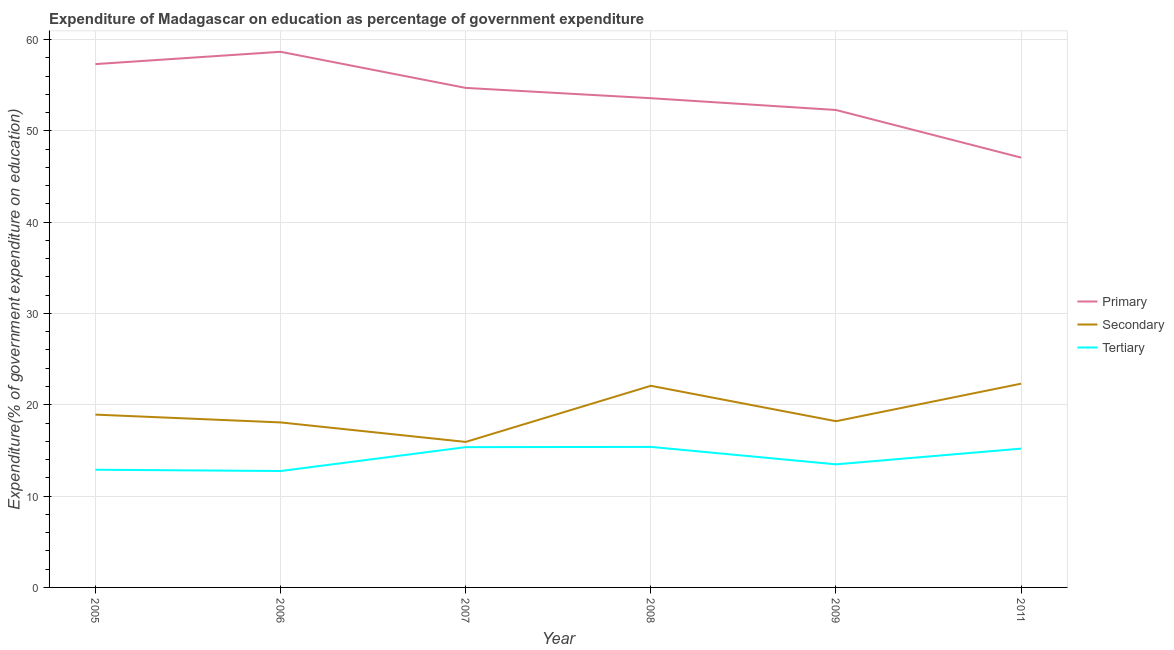Does the line corresponding to expenditure on secondary education intersect with the line corresponding to expenditure on primary education?
Provide a short and direct response. No. What is the expenditure on tertiary education in 2007?
Offer a very short reply. 15.36. Across all years, what is the maximum expenditure on primary education?
Offer a terse response. 58.65. Across all years, what is the minimum expenditure on primary education?
Ensure brevity in your answer.  47.07. In which year was the expenditure on tertiary education maximum?
Offer a terse response. 2008. What is the total expenditure on secondary education in the graph?
Provide a short and direct response. 115.52. What is the difference between the expenditure on primary education in 2005 and that in 2009?
Offer a very short reply. 5.02. What is the difference between the expenditure on primary education in 2006 and the expenditure on tertiary education in 2011?
Provide a succinct answer. 43.45. What is the average expenditure on primary education per year?
Your answer should be very brief. 53.93. In the year 2008, what is the difference between the expenditure on secondary education and expenditure on primary education?
Your answer should be very brief. -31.49. What is the ratio of the expenditure on secondary education in 2005 to that in 2007?
Offer a terse response. 1.19. Is the difference between the expenditure on secondary education in 2005 and 2008 greater than the difference between the expenditure on tertiary education in 2005 and 2008?
Offer a terse response. No. What is the difference between the highest and the second highest expenditure on primary education?
Offer a very short reply. 1.35. What is the difference between the highest and the lowest expenditure on secondary education?
Keep it short and to the point. 6.38. In how many years, is the expenditure on primary education greater than the average expenditure on primary education taken over all years?
Keep it short and to the point. 3. What is the difference between two consecutive major ticks on the Y-axis?
Your answer should be very brief. 10. Are the values on the major ticks of Y-axis written in scientific E-notation?
Provide a succinct answer. No. Does the graph contain any zero values?
Provide a short and direct response. No. Does the graph contain grids?
Provide a succinct answer. Yes. What is the title of the graph?
Make the answer very short. Expenditure of Madagascar on education as percentage of government expenditure. Does "Natural gas sources" appear as one of the legend labels in the graph?
Provide a succinct answer. No. What is the label or title of the Y-axis?
Ensure brevity in your answer.  Expenditure(% of government expenditure on education). What is the Expenditure(% of government expenditure on education) of Primary in 2005?
Provide a short and direct response. 57.31. What is the Expenditure(% of government expenditure on education) of Secondary in 2005?
Give a very brief answer. 18.92. What is the Expenditure(% of government expenditure on education) of Tertiary in 2005?
Offer a terse response. 12.89. What is the Expenditure(% of government expenditure on education) in Primary in 2006?
Your answer should be compact. 58.65. What is the Expenditure(% of government expenditure on education) of Secondary in 2006?
Make the answer very short. 18.07. What is the Expenditure(% of government expenditure on education) of Tertiary in 2006?
Give a very brief answer. 12.75. What is the Expenditure(% of government expenditure on education) in Primary in 2007?
Offer a very short reply. 54.7. What is the Expenditure(% of government expenditure on education) in Secondary in 2007?
Offer a very short reply. 15.93. What is the Expenditure(% of government expenditure on education) of Tertiary in 2007?
Provide a short and direct response. 15.36. What is the Expenditure(% of government expenditure on education) in Primary in 2008?
Offer a very short reply. 53.57. What is the Expenditure(% of government expenditure on education) in Secondary in 2008?
Make the answer very short. 22.08. What is the Expenditure(% of government expenditure on education) in Tertiary in 2008?
Your response must be concise. 15.39. What is the Expenditure(% of government expenditure on education) of Primary in 2009?
Make the answer very short. 52.28. What is the Expenditure(% of government expenditure on education) of Secondary in 2009?
Your response must be concise. 18.2. What is the Expenditure(% of government expenditure on education) of Tertiary in 2009?
Ensure brevity in your answer.  13.48. What is the Expenditure(% of government expenditure on education) in Primary in 2011?
Your answer should be compact. 47.07. What is the Expenditure(% of government expenditure on education) of Secondary in 2011?
Your answer should be very brief. 22.31. What is the Expenditure(% of government expenditure on education) in Tertiary in 2011?
Keep it short and to the point. 15.2. Across all years, what is the maximum Expenditure(% of government expenditure on education) in Primary?
Make the answer very short. 58.65. Across all years, what is the maximum Expenditure(% of government expenditure on education) of Secondary?
Ensure brevity in your answer.  22.31. Across all years, what is the maximum Expenditure(% of government expenditure on education) in Tertiary?
Give a very brief answer. 15.39. Across all years, what is the minimum Expenditure(% of government expenditure on education) of Primary?
Ensure brevity in your answer.  47.07. Across all years, what is the minimum Expenditure(% of government expenditure on education) in Secondary?
Ensure brevity in your answer.  15.93. Across all years, what is the minimum Expenditure(% of government expenditure on education) of Tertiary?
Provide a short and direct response. 12.75. What is the total Expenditure(% of government expenditure on education) in Primary in the graph?
Make the answer very short. 323.58. What is the total Expenditure(% of government expenditure on education) in Secondary in the graph?
Make the answer very short. 115.52. What is the total Expenditure(% of government expenditure on education) of Tertiary in the graph?
Your answer should be very brief. 85.06. What is the difference between the Expenditure(% of government expenditure on education) in Primary in 2005 and that in 2006?
Your answer should be very brief. -1.35. What is the difference between the Expenditure(% of government expenditure on education) of Secondary in 2005 and that in 2006?
Your response must be concise. 0.85. What is the difference between the Expenditure(% of government expenditure on education) in Tertiary in 2005 and that in 2006?
Offer a very short reply. 0.14. What is the difference between the Expenditure(% of government expenditure on education) of Primary in 2005 and that in 2007?
Keep it short and to the point. 2.61. What is the difference between the Expenditure(% of government expenditure on education) of Secondary in 2005 and that in 2007?
Offer a terse response. 2.99. What is the difference between the Expenditure(% of government expenditure on education) in Tertiary in 2005 and that in 2007?
Your answer should be very brief. -2.47. What is the difference between the Expenditure(% of government expenditure on education) in Primary in 2005 and that in 2008?
Keep it short and to the point. 3.73. What is the difference between the Expenditure(% of government expenditure on education) of Secondary in 2005 and that in 2008?
Give a very brief answer. -3.16. What is the difference between the Expenditure(% of government expenditure on education) in Tertiary in 2005 and that in 2008?
Provide a short and direct response. -2.5. What is the difference between the Expenditure(% of government expenditure on education) of Primary in 2005 and that in 2009?
Make the answer very short. 5.02. What is the difference between the Expenditure(% of government expenditure on education) of Secondary in 2005 and that in 2009?
Your answer should be compact. 0.72. What is the difference between the Expenditure(% of government expenditure on education) in Tertiary in 2005 and that in 2009?
Give a very brief answer. -0.59. What is the difference between the Expenditure(% of government expenditure on education) of Primary in 2005 and that in 2011?
Give a very brief answer. 10.24. What is the difference between the Expenditure(% of government expenditure on education) of Secondary in 2005 and that in 2011?
Provide a succinct answer. -3.39. What is the difference between the Expenditure(% of government expenditure on education) of Tertiary in 2005 and that in 2011?
Your answer should be compact. -2.31. What is the difference between the Expenditure(% of government expenditure on education) of Primary in 2006 and that in 2007?
Your answer should be very brief. 3.95. What is the difference between the Expenditure(% of government expenditure on education) in Secondary in 2006 and that in 2007?
Your answer should be compact. 2.14. What is the difference between the Expenditure(% of government expenditure on education) in Tertiary in 2006 and that in 2007?
Provide a succinct answer. -2.62. What is the difference between the Expenditure(% of government expenditure on education) in Primary in 2006 and that in 2008?
Your answer should be compact. 5.08. What is the difference between the Expenditure(% of government expenditure on education) of Secondary in 2006 and that in 2008?
Offer a very short reply. -4.01. What is the difference between the Expenditure(% of government expenditure on education) of Tertiary in 2006 and that in 2008?
Provide a succinct answer. -2.64. What is the difference between the Expenditure(% of government expenditure on education) of Primary in 2006 and that in 2009?
Provide a succinct answer. 6.37. What is the difference between the Expenditure(% of government expenditure on education) of Secondary in 2006 and that in 2009?
Give a very brief answer. -0.13. What is the difference between the Expenditure(% of government expenditure on education) in Tertiary in 2006 and that in 2009?
Make the answer very short. -0.73. What is the difference between the Expenditure(% of government expenditure on education) in Primary in 2006 and that in 2011?
Offer a terse response. 11.59. What is the difference between the Expenditure(% of government expenditure on education) of Secondary in 2006 and that in 2011?
Offer a very short reply. -4.24. What is the difference between the Expenditure(% of government expenditure on education) in Tertiary in 2006 and that in 2011?
Your response must be concise. -2.45. What is the difference between the Expenditure(% of government expenditure on education) of Primary in 2007 and that in 2008?
Offer a terse response. 1.13. What is the difference between the Expenditure(% of government expenditure on education) in Secondary in 2007 and that in 2008?
Your response must be concise. -6.15. What is the difference between the Expenditure(% of government expenditure on education) of Tertiary in 2007 and that in 2008?
Provide a short and direct response. -0.03. What is the difference between the Expenditure(% of government expenditure on education) of Primary in 2007 and that in 2009?
Give a very brief answer. 2.42. What is the difference between the Expenditure(% of government expenditure on education) in Secondary in 2007 and that in 2009?
Make the answer very short. -2.27. What is the difference between the Expenditure(% of government expenditure on education) in Tertiary in 2007 and that in 2009?
Your response must be concise. 1.88. What is the difference between the Expenditure(% of government expenditure on education) of Primary in 2007 and that in 2011?
Your answer should be very brief. 7.63. What is the difference between the Expenditure(% of government expenditure on education) of Secondary in 2007 and that in 2011?
Keep it short and to the point. -6.38. What is the difference between the Expenditure(% of government expenditure on education) in Tertiary in 2007 and that in 2011?
Your answer should be compact. 0.16. What is the difference between the Expenditure(% of government expenditure on education) of Primary in 2008 and that in 2009?
Your answer should be compact. 1.29. What is the difference between the Expenditure(% of government expenditure on education) in Secondary in 2008 and that in 2009?
Your answer should be very brief. 3.88. What is the difference between the Expenditure(% of government expenditure on education) in Tertiary in 2008 and that in 2009?
Provide a short and direct response. 1.91. What is the difference between the Expenditure(% of government expenditure on education) in Primary in 2008 and that in 2011?
Ensure brevity in your answer.  6.51. What is the difference between the Expenditure(% of government expenditure on education) of Secondary in 2008 and that in 2011?
Provide a succinct answer. -0.23. What is the difference between the Expenditure(% of government expenditure on education) of Tertiary in 2008 and that in 2011?
Provide a short and direct response. 0.19. What is the difference between the Expenditure(% of government expenditure on education) of Primary in 2009 and that in 2011?
Provide a short and direct response. 5.22. What is the difference between the Expenditure(% of government expenditure on education) of Secondary in 2009 and that in 2011?
Offer a terse response. -4.11. What is the difference between the Expenditure(% of government expenditure on education) of Tertiary in 2009 and that in 2011?
Your answer should be compact. -1.72. What is the difference between the Expenditure(% of government expenditure on education) in Primary in 2005 and the Expenditure(% of government expenditure on education) in Secondary in 2006?
Give a very brief answer. 39.24. What is the difference between the Expenditure(% of government expenditure on education) of Primary in 2005 and the Expenditure(% of government expenditure on education) of Tertiary in 2006?
Give a very brief answer. 44.56. What is the difference between the Expenditure(% of government expenditure on education) of Secondary in 2005 and the Expenditure(% of government expenditure on education) of Tertiary in 2006?
Keep it short and to the point. 6.18. What is the difference between the Expenditure(% of government expenditure on education) of Primary in 2005 and the Expenditure(% of government expenditure on education) of Secondary in 2007?
Ensure brevity in your answer.  41.37. What is the difference between the Expenditure(% of government expenditure on education) of Primary in 2005 and the Expenditure(% of government expenditure on education) of Tertiary in 2007?
Offer a very short reply. 41.94. What is the difference between the Expenditure(% of government expenditure on education) in Secondary in 2005 and the Expenditure(% of government expenditure on education) in Tertiary in 2007?
Ensure brevity in your answer.  3.56. What is the difference between the Expenditure(% of government expenditure on education) of Primary in 2005 and the Expenditure(% of government expenditure on education) of Secondary in 2008?
Ensure brevity in your answer.  35.23. What is the difference between the Expenditure(% of government expenditure on education) in Primary in 2005 and the Expenditure(% of government expenditure on education) in Tertiary in 2008?
Make the answer very short. 41.92. What is the difference between the Expenditure(% of government expenditure on education) in Secondary in 2005 and the Expenditure(% of government expenditure on education) in Tertiary in 2008?
Provide a succinct answer. 3.54. What is the difference between the Expenditure(% of government expenditure on education) of Primary in 2005 and the Expenditure(% of government expenditure on education) of Secondary in 2009?
Your response must be concise. 39.1. What is the difference between the Expenditure(% of government expenditure on education) of Primary in 2005 and the Expenditure(% of government expenditure on education) of Tertiary in 2009?
Ensure brevity in your answer.  43.83. What is the difference between the Expenditure(% of government expenditure on education) of Secondary in 2005 and the Expenditure(% of government expenditure on education) of Tertiary in 2009?
Provide a succinct answer. 5.45. What is the difference between the Expenditure(% of government expenditure on education) of Primary in 2005 and the Expenditure(% of government expenditure on education) of Secondary in 2011?
Your response must be concise. 34.99. What is the difference between the Expenditure(% of government expenditure on education) in Primary in 2005 and the Expenditure(% of government expenditure on education) in Tertiary in 2011?
Make the answer very short. 42.11. What is the difference between the Expenditure(% of government expenditure on education) in Secondary in 2005 and the Expenditure(% of government expenditure on education) in Tertiary in 2011?
Provide a succinct answer. 3.72. What is the difference between the Expenditure(% of government expenditure on education) of Primary in 2006 and the Expenditure(% of government expenditure on education) of Secondary in 2007?
Keep it short and to the point. 42.72. What is the difference between the Expenditure(% of government expenditure on education) of Primary in 2006 and the Expenditure(% of government expenditure on education) of Tertiary in 2007?
Provide a short and direct response. 43.29. What is the difference between the Expenditure(% of government expenditure on education) of Secondary in 2006 and the Expenditure(% of government expenditure on education) of Tertiary in 2007?
Give a very brief answer. 2.71. What is the difference between the Expenditure(% of government expenditure on education) of Primary in 2006 and the Expenditure(% of government expenditure on education) of Secondary in 2008?
Make the answer very short. 36.58. What is the difference between the Expenditure(% of government expenditure on education) in Primary in 2006 and the Expenditure(% of government expenditure on education) in Tertiary in 2008?
Offer a very short reply. 43.27. What is the difference between the Expenditure(% of government expenditure on education) in Secondary in 2006 and the Expenditure(% of government expenditure on education) in Tertiary in 2008?
Your response must be concise. 2.68. What is the difference between the Expenditure(% of government expenditure on education) in Primary in 2006 and the Expenditure(% of government expenditure on education) in Secondary in 2009?
Your response must be concise. 40.45. What is the difference between the Expenditure(% of government expenditure on education) of Primary in 2006 and the Expenditure(% of government expenditure on education) of Tertiary in 2009?
Keep it short and to the point. 45.18. What is the difference between the Expenditure(% of government expenditure on education) of Secondary in 2006 and the Expenditure(% of government expenditure on education) of Tertiary in 2009?
Provide a short and direct response. 4.59. What is the difference between the Expenditure(% of government expenditure on education) in Primary in 2006 and the Expenditure(% of government expenditure on education) in Secondary in 2011?
Offer a terse response. 36.34. What is the difference between the Expenditure(% of government expenditure on education) of Primary in 2006 and the Expenditure(% of government expenditure on education) of Tertiary in 2011?
Ensure brevity in your answer.  43.45. What is the difference between the Expenditure(% of government expenditure on education) in Secondary in 2006 and the Expenditure(% of government expenditure on education) in Tertiary in 2011?
Keep it short and to the point. 2.87. What is the difference between the Expenditure(% of government expenditure on education) of Primary in 2007 and the Expenditure(% of government expenditure on education) of Secondary in 2008?
Your response must be concise. 32.62. What is the difference between the Expenditure(% of government expenditure on education) of Primary in 2007 and the Expenditure(% of government expenditure on education) of Tertiary in 2008?
Offer a very short reply. 39.31. What is the difference between the Expenditure(% of government expenditure on education) in Secondary in 2007 and the Expenditure(% of government expenditure on education) in Tertiary in 2008?
Make the answer very short. 0.55. What is the difference between the Expenditure(% of government expenditure on education) of Primary in 2007 and the Expenditure(% of government expenditure on education) of Secondary in 2009?
Make the answer very short. 36.5. What is the difference between the Expenditure(% of government expenditure on education) in Primary in 2007 and the Expenditure(% of government expenditure on education) in Tertiary in 2009?
Make the answer very short. 41.22. What is the difference between the Expenditure(% of government expenditure on education) in Secondary in 2007 and the Expenditure(% of government expenditure on education) in Tertiary in 2009?
Give a very brief answer. 2.46. What is the difference between the Expenditure(% of government expenditure on education) in Primary in 2007 and the Expenditure(% of government expenditure on education) in Secondary in 2011?
Keep it short and to the point. 32.39. What is the difference between the Expenditure(% of government expenditure on education) of Primary in 2007 and the Expenditure(% of government expenditure on education) of Tertiary in 2011?
Offer a very short reply. 39.5. What is the difference between the Expenditure(% of government expenditure on education) in Secondary in 2007 and the Expenditure(% of government expenditure on education) in Tertiary in 2011?
Your answer should be very brief. 0.73. What is the difference between the Expenditure(% of government expenditure on education) of Primary in 2008 and the Expenditure(% of government expenditure on education) of Secondary in 2009?
Ensure brevity in your answer.  35.37. What is the difference between the Expenditure(% of government expenditure on education) of Primary in 2008 and the Expenditure(% of government expenditure on education) of Tertiary in 2009?
Ensure brevity in your answer.  40.09. What is the difference between the Expenditure(% of government expenditure on education) of Secondary in 2008 and the Expenditure(% of government expenditure on education) of Tertiary in 2009?
Your answer should be compact. 8.6. What is the difference between the Expenditure(% of government expenditure on education) in Primary in 2008 and the Expenditure(% of government expenditure on education) in Secondary in 2011?
Offer a very short reply. 31.26. What is the difference between the Expenditure(% of government expenditure on education) in Primary in 2008 and the Expenditure(% of government expenditure on education) in Tertiary in 2011?
Your answer should be very brief. 38.37. What is the difference between the Expenditure(% of government expenditure on education) of Secondary in 2008 and the Expenditure(% of government expenditure on education) of Tertiary in 2011?
Your answer should be compact. 6.88. What is the difference between the Expenditure(% of government expenditure on education) in Primary in 2009 and the Expenditure(% of government expenditure on education) in Secondary in 2011?
Your answer should be very brief. 29.97. What is the difference between the Expenditure(% of government expenditure on education) of Primary in 2009 and the Expenditure(% of government expenditure on education) of Tertiary in 2011?
Your response must be concise. 37.08. What is the difference between the Expenditure(% of government expenditure on education) in Secondary in 2009 and the Expenditure(% of government expenditure on education) in Tertiary in 2011?
Your answer should be very brief. 3. What is the average Expenditure(% of government expenditure on education) of Primary per year?
Your response must be concise. 53.93. What is the average Expenditure(% of government expenditure on education) in Secondary per year?
Keep it short and to the point. 19.25. What is the average Expenditure(% of government expenditure on education) of Tertiary per year?
Your answer should be compact. 14.18. In the year 2005, what is the difference between the Expenditure(% of government expenditure on education) of Primary and Expenditure(% of government expenditure on education) of Secondary?
Keep it short and to the point. 38.38. In the year 2005, what is the difference between the Expenditure(% of government expenditure on education) in Primary and Expenditure(% of government expenditure on education) in Tertiary?
Your response must be concise. 44.42. In the year 2005, what is the difference between the Expenditure(% of government expenditure on education) in Secondary and Expenditure(% of government expenditure on education) in Tertiary?
Ensure brevity in your answer.  6.03. In the year 2006, what is the difference between the Expenditure(% of government expenditure on education) of Primary and Expenditure(% of government expenditure on education) of Secondary?
Provide a succinct answer. 40.59. In the year 2006, what is the difference between the Expenditure(% of government expenditure on education) of Primary and Expenditure(% of government expenditure on education) of Tertiary?
Give a very brief answer. 45.91. In the year 2006, what is the difference between the Expenditure(% of government expenditure on education) in Secondary and Expenditure(% of government expenditure on education) in Tertiary?
Provide a succinct answer. 5.32. In the year 2007, what is the difference between the Expenditure(% of government expenditure on education) of Primary and Expenditure(% of government expenditure on education) of Secondary?
Ensure brevity in your answer.  38.77. In the year 2007, what is the difference between the Expenditure(% of government expenditure on education) of Primary and Expenditure(% of government expenditure on education) of Tertiary?
Keep it short and to the point. 39.34. In the year 2007, what is the difference between the Expenditure(% of government expenditure on education) of Secondary and Expenditure(% of government expenditure on education) of Tertiary?
Make the answer very short. 0.57. In the year 2008, what is the difference between the Expenditure(% of government expenditure on education) of Primary and Expenditure(% of government expenditure on education) of Secondary?
Ensure brevity in your answer.  31.49. In the year 2008, what is the difference between the Expenditure(% of government expenditure on education) in Primary and Expenditure(% of government expenditure on education) in Tertiary?
Offer a terse response. 38.18. In the year 2008, what is the difference between the Expenditure(% of government expenditure on education) in Secondary and Expenditure(% of government expenditure on education) in Tertiary?
Ensure brevity in your answer.  6.69. In the year 2009, what is the difference between the Expenditure(% of government expenditure on education) of Primary and Expenditure(% of government expenditure on education) of Secondary?
Your response must be concise. 34.08. In the year 2009, what is the difference between the Expenditure(% of government expenditure on education) of Primary and Expenditure(% of government expenditure on education) of Tertiary?
Give a very brief answer. 38.8. In the year 2009, what is the difference between the Expenditure(% of government expenditure on education) of Secondary and Expenditure(% of government expenditure on education) of Tertiary?
Offer a terse response. 4.72. In the year 2011, what is the difference between the Expenditure(% of government expenditure on education) in Primary and Expenditure(% of government expenditure on education) in Secondary?
Offer a terse response. 24.75. In the year 2011, what is the difference between the Expenditure(% of government expenditure on education) of Primary and Expenditure(% of government expenditure on education) of Tertiary?
Keep it short and to the point. 31.87. In the year 2011, what is the difference between the Expenditure(% of government expenditure on education) of Secondary and Expenditure(% of government expenditure on education) of Tertiary?
Keep it short and to the point. 7.11. What is the ratio of the Expenditure(% of government expenditure on education) of Secondary in 2005 to that in 2006?
Offer a very short reply. 1.05. What is the ratio of the Expenditure(% of government expenditure on education) of Tertiary in 2005 to that in 2006?
Your answer should be very brief. 1.01. What is the ratio of the Expenditure(% of government expenditure on education) in Primary in 2005 to that in 2007?
Provide a short and direct response. 1.05. What is the ratio of the Expenditure(% of government expenditure on education) of Secondary in 2005 to that in 2007?
Give a very brief answer. 1.19. What is the ratio of the Expenditure(% of government expenditure on education) of Tertiary in 2005 to that in 2007?
Keep it short and to the point. 0.84. What is the ratio of the Expenditure(% of government expenditure on education) of Primary in 2005 to that in 2008?
Your response must be concise. 1.07. What is the ratio of the Expenditure(% of government expenditure on education) in Tertiary in 2005 to that in 2008?
Provide a succinct answer. 0.84. What is the ratio of the Expenditure(% of government expenditure on education) in Primary in 2005 to that in 2009?
Your answer should be compact. 1.1. What is the ratio of the Expenditure(% of government expenditure on education) in Secondary in 2005 to that in 2009?
Your answer should be very brief. 1.04. What is the ratio of the Expenditure(% of government expenditure on education) in Tertiary in 2005 to that in 2009?
Offer a terse response. 0.96. What is the ratio of the Expenditure(% of government expenditure on education) in Primary in 2005 to that in 2011?
Make the answer very short. 1.22. What is the ratio of the Expenditure(% of government expenditure on education) in Secondary in 2005 to that in 2011?
Offer a very short reply. 0.85. What is the ratio of the Expenditure(% of government expenditure on education) of Tertiary in 2005 to that in 2011?
Provide a succinct answer. 0.85. What is the ratio of the Expenditure(% of government expenditure on education) in Primary in 2006 to that in 2007?
Provide a succinct answer. 1.07. What is the ratio of the Expenditure(% of government expenditure on education) of Secondary in 2006 to that in 2007?
Your answer should be compact. 1.13. What is the ratio of the Expenditure(% of government expenditure on education) of Tertiary in 2006 to that in 2007?
Keep it short and to the point. 0.83. What is the ratio of the Expenditure(% of government expenditure on education) in Primary in 2006 to that in 2008?
Offer a very short reply. 1.09. What is the ratio of the Expenditure(% of government expenditure on education) in Secondary in 2006 to that in 2008?
Ensure brevity in your answer.  0.82. What is the ratio of the Expenditure(% of government expenditure on education) of Tertiary in 2006 to that in 2008?
Offer a terse response. 0.83. What is the ratio of the Expenditure(% of government expenditure on education) in Primary in 2006 to that in 2009?
Ensure brevity in your answer.  1.12. What is the ratio of the Expenditure(% of government expenditure on education) of Secondary in 2006 to that in 2009?
Offer a very short reply. 0.99. What is the ratio of the Expenditure(% of government expenditure on education) of Tertiary in 2006 to that in 2009?
Offer a terse response. 0.95. What is the ratio of the Expenditure(% of government expenditure on education) of Primary in 2006 to that in 2011?
Your response must be concise. 1.25. What is the ratio of the Expenditure(% of government expenditure on education) of Secondary in 2006 to that in 2011?
Offer a terse response. 0.81. What is the ratio of the Expenditure(% of government expenditure on education) in Tertiary in 2006 to that in 2011?
Offer a very short reply. 0.84. What is the ratio of the Expenditure(% of government expenditure on education) of Primary in 2007 to that in 2008?
Offer a very short reply. 1.02. What is the ratio of the Expenditure(% of government expenditure on education) of Secondary in 2007 to that in 2008?
Keep it short and to the point. 0.72. What is the ratio of the Expenditure(% of government expenditure on education) of Primary in 2007 to that in 2009?
Give a very brief answer. 1.05. What is the ratio of the Expenditure(% of government expenditure on education) of Secondary in 2007 to that in 2009?
Your answer should be compact. 0.88. What is the ratio of the Expenditure(% of government expenditure on education) in Tertiary in 2007 to that in 2009?
Make the answer very short. 1.14. What is the ratio of the Expenditure(% of government expenditure on education) of Primary in 2007 to that in 2011?
Your response must be concise. 1.16. What is the ratio of the Expenditure(% of government expenditure on education) of Secondary in 2007 to that in 2011?
Ensure brevity in your answer.  0.71. What is the ratio of the Expenditure(% of government expenditure on education) in Tertiary in 2007 to that in 2011?
Give a very brief answer. 1.01. What is the ratio of the Expenditure(% of government expenditure on education) of Primary in 2008 to that in 2009?
Offer a terse response. 1.02. What is the ratio of the Expenditure(% of government expenditure on education) in Secondary in 2008 to that in 2009?
Your response must be concise. 1.21. What is the ratio of the Expenditure(% of government expenditure on education) of Tertiary in 2008 to that in 2009?
Give a very brief answer. 1.14. What is the ratio of the Expenditure(% of government expenditure on education) in Primary in 2008 to that in 2011?
Offer a terse response. 1.14. What is the ratio of the Expenditure(% of government expenditure on education) in Tertiary in 2008 to that in 2011?
Provide a short and direct response. 1.01. What is the ratio of the Expenditure(% of government expenditure on education) of Primary in 2009 to that in 2011?
Ensure brevity in your answer.  1.11. What is the ratio of the Expenditure(% of government expenditure on education) of Secondary in 2009 to that in 2011?
Your answer should be compact. 0.82. What is the ratio of the Expenditure(% of government expenditure on education) of Tertiary in 2009 to that in 2011?
Make the answer very short. 0.89. What is the difference between the highest and the second highest Expenditure(% of government expenditure on education) in Primary?
Ensure brevity in your answer.  1.35. What is the difference between the highest and the second highest Expenditure(% of government expenditure on education) in Secondary?
Offer a very short reply. 0.23. What is the difference between the highest and the second highest Expenditure(% of government expenditure on education) of Tertiary?
Your response must be concise. 0.03. What is the difference between the highest and the lowest Expenditure(% of government expenditure on education) of Primary?
Your response must be concise. 11.59. What is the difference between the highest and the lowest Expenditure(% of government expenditure on education) in Secondary?
Provide a succinct answer. 6.38. What is the difference between the highest and the lowest Expenditure(% of government expenditure on education) of Tertiary?
Ensure brevity in your answer.  2.64. 